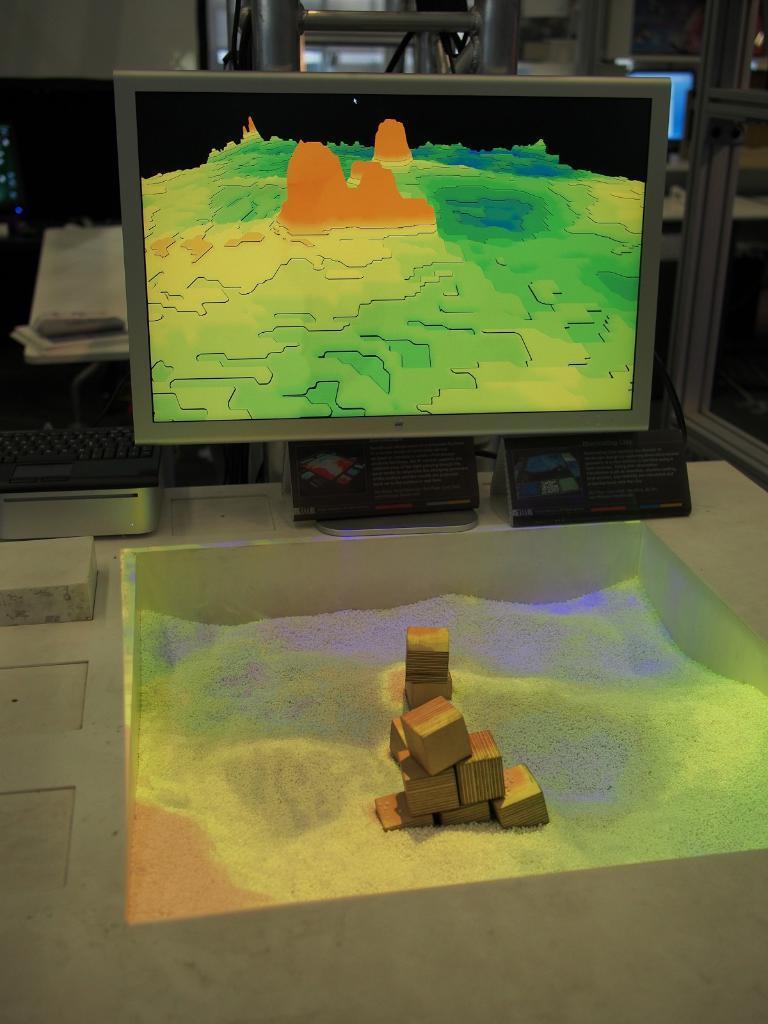How would you summarize this image in a sentence or two? In this image I can see few wooden blocks on the colorful sand. In the background I can see the monitor. To the left I can see the keyboard. Behind the monitor I can see few metal rods and few electronic devices. 